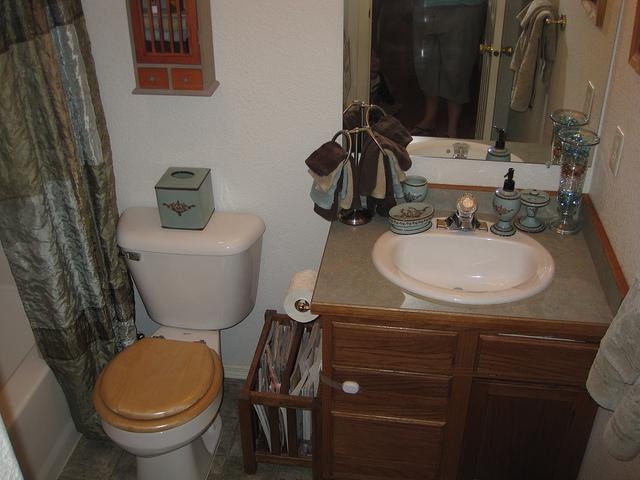What is the box on the toilet tank used for? tissue 